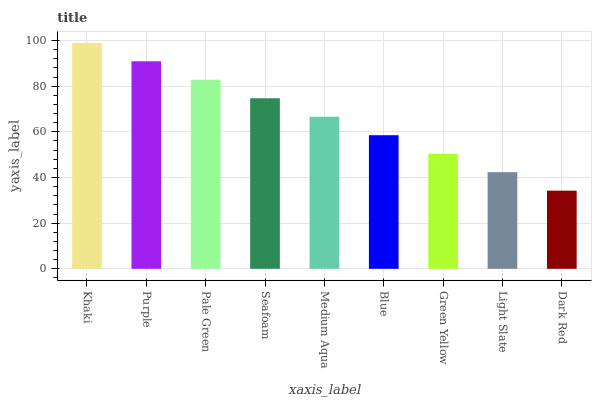Is Dark Red the minimum?
Answer yes or no. Yes. Is Khaki the maximum?
Answer yes or no. Yes. Is Purple the minimum?
Answer yes or no. No. Is Purple the maximum?
Answer yes or no. No. Is Khaki greater than Purple?
Answer yes or no. Yes. Is Purple less than Khaki?
Answer yes or no. Yes. Is Purple greater than Khaki?
Answer yes or no. No. Is Khaki less than Purple?
Answer yes or no. No. Is Medium Aqua the high median?
Answer yes or no. Yes. Is Medium Aqua the low median?
Answer yes or no. Yes. Is Blue the high median?
Answer yes or no. No. Is Dark Red the low median?
Answer yes or no. No. 